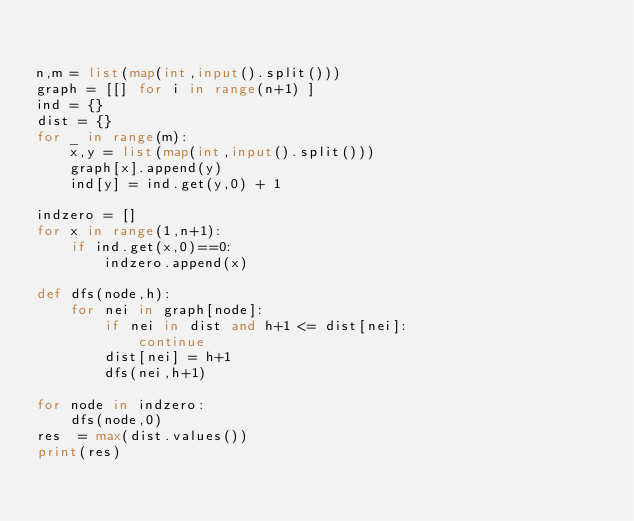Convert code to text. <code><loc_0><loc_0><loc_500><loc_500><_Python_>

n,m = list(map(int,input().split()))
graph = [[] for i in range(n+1) ]
ind = {}
dist = {}
for _ in range(m):
    x,y = list(map(int,input().split()))
    graph[x].append(y)
    ind[y] = ind.get(y,0) + 1

indzero = []
for x in range(1,n+1):
    if ind.get(x,0)==0:
        indzero.append(x)
        
def dfs(node,h):
    for nei in graph[node]:
        if nei in dist and h+1 <= dist[nei]:
            continue
        dist[nei] = h+1
        dfs(nei,h+1)
        
for node in indzero:
    dfs(node,0)
res  = max(dist.values()) 
print(res)
</code> 